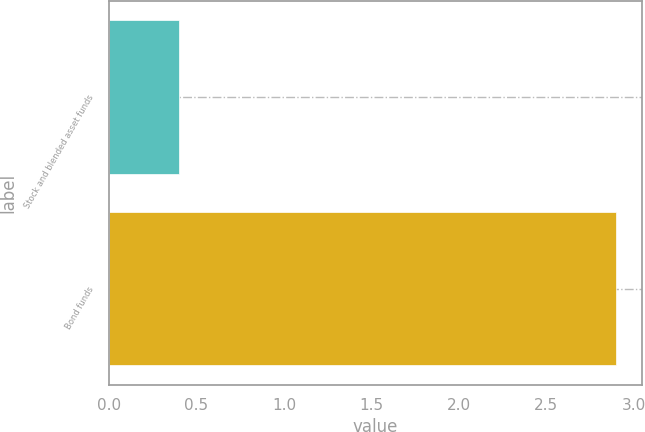Convert chart to OTSL. <chart><loc_0><loc_0><loc_500><loc_500><bar_chart><fcel>Stock and blended asset funds<fcel>Bond funds<nl><fcel>0.4<fcel>2.9<nl></chart> 